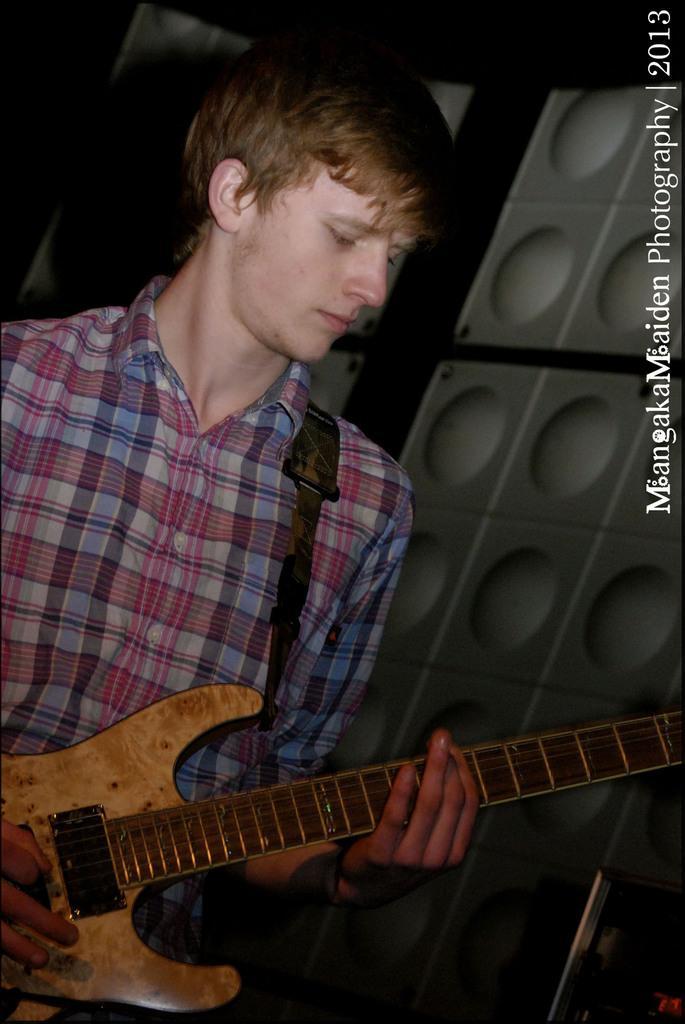In one or two sentences, can you explain what this image depicts? In this image, in the left side there is a boy standing and holding a music instrument which is in yellow color, in the background there is a white color wall. 